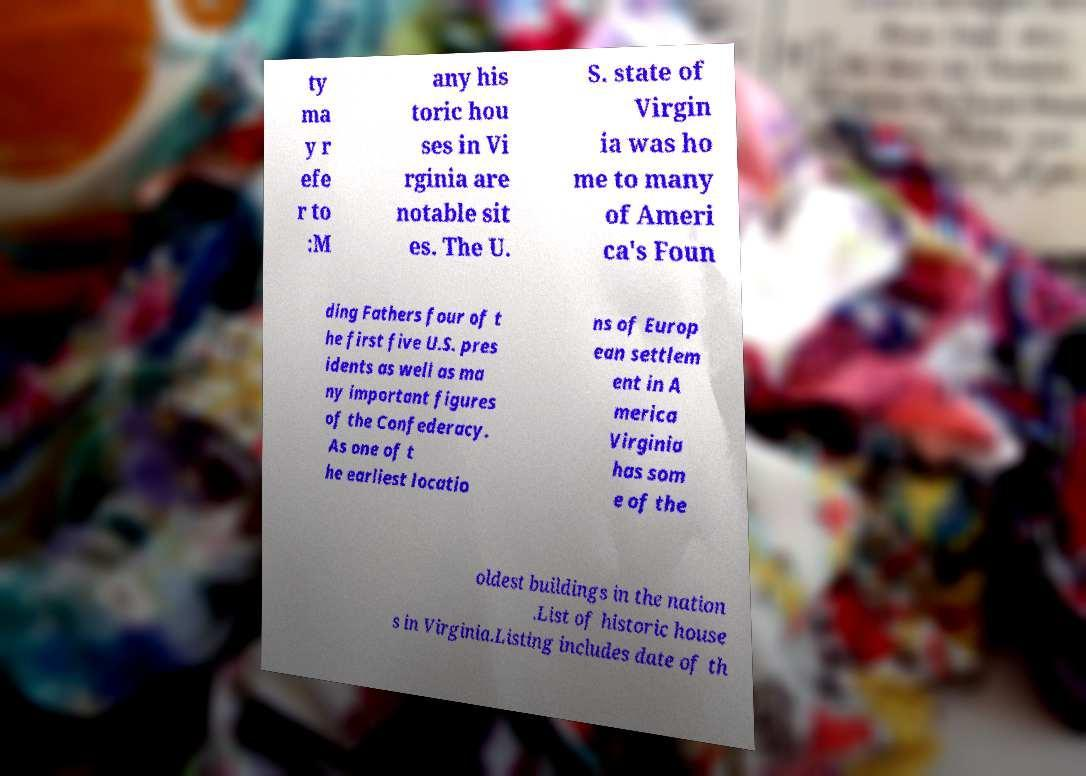Can you accurately transcribe the text from the provided image for me? ty ma y r efe r to :M any his toric hou ses in Vi rginia are notable sit es. The U. S. state of Virgin ia was ho me to many of Ameri ca's Foun ding Fathers four of t he first five U.S. pres idents as well as ma ny important figures of the Confederacy. As one of t he earliest locatio ns of Europ ean settlem ent in A merica Virginia has som e of the oldest buildings in the nation .List of historic house s in Virginia.Listing includes date of th 